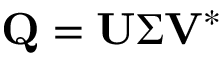<formula> <loc_0><loc_0><loc_500><loc_500>Q = U \Sigma V ^ { * }</formula> 